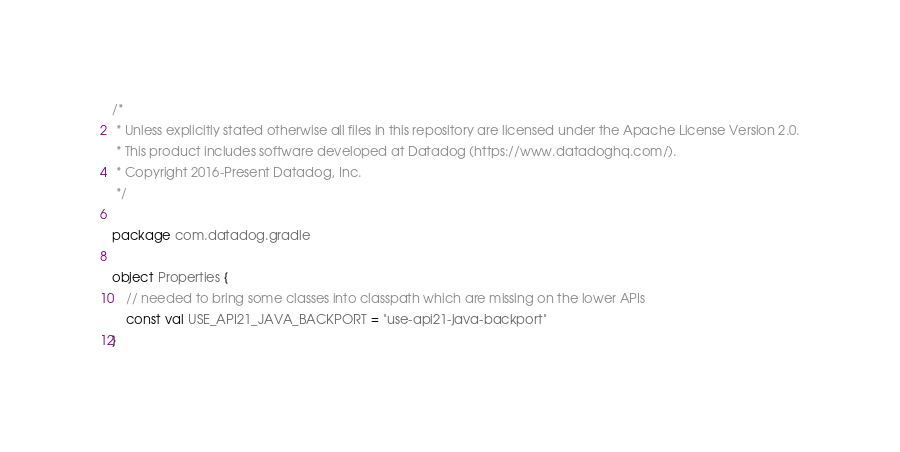Convert code to text. <code><loc_0><loc_0><loc_500><loc_500><_Kotlin_>/*
 * Unless explicitly stated otherwise all files in this repository are licensed under the Apache License Version 2.0.
 * This product includes software developed at Datadog (https://www.datadoghq.com/).
 * Copyright 2016-Present Datadog, Inc.
 */

package com.datadog.gradle

object Properties {
    // needed to bring some classes into classpath which are missing on the lower APIs
    const val USE_API21_JAVA_BACKPORT = "use-api21-java-backport"
}</code> 